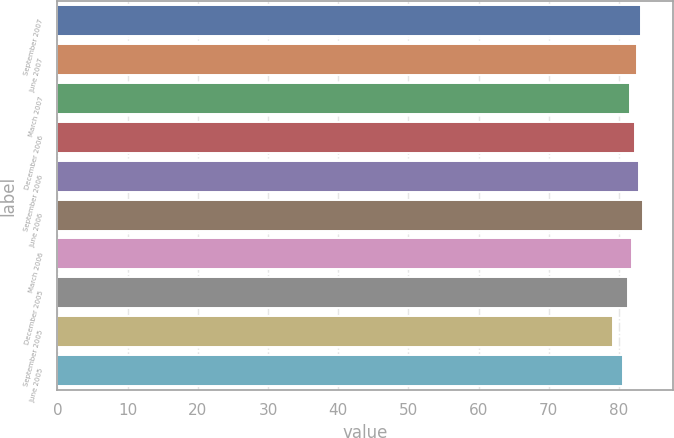Convert chart to OTSL. <chart><loc_0><loc_0><loc_500><loc_500><bar_chart><fcel>September 2007<fcel>June 2007<fcel>March 2007<fcel>December 2006<fcel>September 2006<fcel>June 2006<fcel>March 2006<fcel>December 2005<fcel>September 2005<fcel>June 2005<nl><fcel>83.16<fcel>82.54<fcel>81.61<fcel>82.23<fcel>82.85<fcel>83.47<fcel>81.92<fcel>81.3<fcel>79.2<fcel>80.6<nl></chart> 